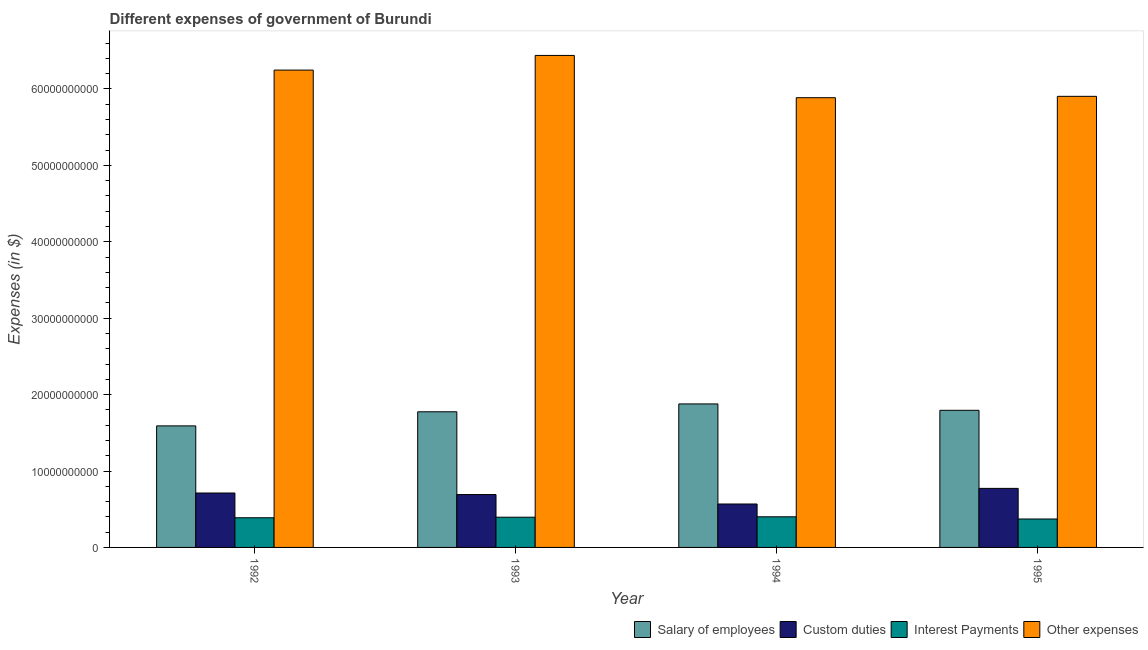How many different coloured bars are there?
Your response must be concise. 4. Are the number of bars per tick equal to the number of legend labels?
Your answer should be compact. Yes. Are the number of bars on each tick of the X-axis equal?
Your response must be concise. Yes. How many bars are there on the 1st tick from the right?
Ensure brevity in your answer.  4. What is the label of the 2nd group of bars from the left?
Your answer should be compact. 1993. What is the amount spent on interest payments in 1993?
Offer a terse response. 3.96e+09. Across all years, what is the maximum amount spent on interest payments?
Your response must be concise. 4.01e+09. Across all years, what is the minimum amount spent on custom duties?
Keep it short and to the point. 5.68e+09. In which year was the amount spent on other expenses minimum?
Your answer should be very brief. 1994. What is the total amount spent on salary of employees in the graph?
Provide a succinct answer. 7.04e+1. What is the difference between the amount spent on interest payments in 1993 and that in 1994?
Your answer should be compact. -5.20e+07. What is the difference between the amount spent on other expenses in 1993 and the amount spent on interest payments in 1995?
Your answer should be compact. 5.35e+09. What is the average amount spent on interest payments per year?
Your answer should be very brief. 3.89e+09. In how many years, is the amount spent on custom duties greater than 24000000000 $?
Keep it short and to the point. 0. What is the ratio of the amount spent on salary of employees in 1994 to that in 1995?
Your answer should be compact. 1.05. What is the difference between the highest and the second highest amount spent on interest payments?
Give a very brief answer. 5.20e+07. What is the difference between the highest and the lowest amount spent on salary of employees?
Offer a terse response. 2.87e+09. In how many years, is the amount spent on interest payments greater than the average amount spent on interest payments taken over all years?
Your response must be concise. 2. Is it the case that in every year, the sum of the amount spent on custom duties and amount spent on salary of employees is greater than the sum of amount spent on interest payments and amount spent on other expenses?
Ensure brevity in your answer.  No. What does the 4th bar from the left in 1993 represents?
Your answer should be very brief. Other expenses. What does the 3rd bar from the right in 1995 represents?
Your response must be concise. Custom duties. How many bars are there?
Give a very brief answer. 16. Are the values on the major ticks of Y-axis written in scientific E-notation?
Keep it short and to the point. No. Does the graph contain any zero values?
Ensure brevity in your answer.  No. Does the graph contain grids?
Your answer should be compact. No. Where does the legend appear in the graph?
Provide a short and direct response. Bottom right. How are the legend labels stacked?
Your response must be concise. Horizontal. What is the title of the graph?
Offer a very short reply. Different expenses of government of Burundi. What is the label or title of the X-axis?
Ensure brevity in your answer.  Year. What is the label or title of the Y-axis?
Offer a very short reply. Expenses (in $). What is the Expenses (in $) of Salary of employees in 1992?
Ensure brevity in your answer.  1.59e+1. What is the Expenses (in $) in Custom duties in 1992?
Give a very brief answer. 7.12e+09. What is the Expenses (in $) of Interest Payments in 1992?
Offer a terse response. 3.88e+09. What is the Expenses (in $) of Other expenses in 1992?
Make the answer very short. 6.25e+1. What is the Expenses (in $) in Salary of employees in 1993?
Your answer should be very brief. 1.78e+1. What is the Expenses (in $) of Custom duties in 1993?
Your answer should be very brief. 6.92e+09. What is the Expenses (in $) in Interest Payments in 1993?
Make the answer very short. 3.96e+09. What is the Expenses (in $) of Other expenses in 1993?
Ensure brevity in your answer.  6.44e+1. What is the Expenses (in $) in Salary of employees in 1994?
Ensure brevity in your answer.  1.88e+1. What is the Expenses (in $) in Custom duties in 1994?
Give a very brief answer. 5.68e+09. What is the Expenses (in $) in Interest Payments in 1994?
Provide a short and direct response. 4.01e+09. What is the Expenses (in $) of Other expenses in 1994?
Offer a terse response. 5.89e+1. What is the Expenses (in $) in Salary of employees in 1995?
Offer a very short reply. 1.79e+1. What is the Expenses (in $) of Custom duties in 1995?
Offer a very short reply. 7.73e+09. What is the Expenses (in $) in Interest Payments in 1995?
Offer a very short reply. 3.72e+09. What is the Expenses (in $) of Other expenses in 1995?
Provide a short and direct response. 5.90e+1. Across all years, what is the maximum Expenses (in $) of Salary of employees?
Make the answer very short. 1.88e+1. Across all years, what is the maximum Expenses (in $) in Custom duties?
Provide a succinct answer. 7.73e+09. Across all years, what is the maximum Expenses (in $) of Interest Payments?
Offer a very short reply. 4.01e+09. Across all years, what is the maximum Expenses (in $) in Other expenses?
Your response must be concise. 6.44e+1. Across all years, what is the minimum Expenses (in $) in Salary of employees?
Offer a very short reply. 1.59e+1. Across all years, what is the minimum Expenses (in $) in Custom duties?
Offer a very short reply. 5.68e+09. Across all years, what is the minimum Expenses (in $) of Interest Payments?
Offer a terse response. 3.72e+09. Across all years, what is the minimum Expenses (in $) in Other expenses?
Your answer should be very brief. 5.89e+1. What is the total Expenses (in $) in Salary of employees in the graph?
Your answer should be compact. 7.04e+1. What is the total Expenses (in $) of Custom duties in the graph?
Keep it short and to the point. 2.75e+1. What is the total Expenses (in $) in Interest Payments in the graph?
Offer a terse response. 1.56e+1. What is the total Expenses (in $) of Other expenses in the graph?
Your answer should be very brief. 2.45e+11. What is the difference between the Expenses (in $) in Salary of employees in 1992 and that in 1993?
Give a very brief answer. -1.84e+09. What is the difference between the Expenses (in $) of Custom duties in 1992 and that in 1993?
Ensure brevity in your answer.  2.04e+08. What is the difference between the Expenses (in $) in Interest Payments in 1992 and that in 1993?
Offer a terse response. -7.20e+07. What is the difference between the Expenses (in $) of Other expenses in 1992 and that in 1993?
Offer a terse response. -1.92e+09. What is the difference between the Expenses (in $) of Salary of employees in 1992 and that in 1994?
Provide a short and direct response. -2.87e+09. What is the difference between the Expenses (in $) in Custom duties in 1992 and that in 1994?
Ensure brevity in your answer.  1.44e+09. What is the difference between the Expenses (in $) in Interest Payments in 1992 and that in 1994?
Make the answer very short. -1.24e+08. What is the difference between the Expenses (in $) of Other expenses in 1992 and that in 1994?
Offer a very short reply. 3.62e+09. What is the difference between the Expenses (in $) in Salary of employees in 1992 and that in 1995?
Make the answer very short. -2.04e+09. What is the difference between the Expenses (in $) of Custom duties in 1992 and that in 1995?
Keep it short and to the point. -6.04e+08. What is the difference between the Expenses (in $) in Interest Payments in 1992 and that in 1995?
Your response must be concise. 1.61e+08. What is the difference between the Expenses (in $) in Other expenses in 1992 and that in 1995?
Your response must be concise. 3.44e+09. What is the difference between the Expenses (in $) in Salary of employees in 1993 and that in 1994?
Keep it short and to the point. -1.03e+09. What is the difference between the Expenses (in $) in Custom duties in 1993 and that in 1994?
Offer a very short reply. 1.24e+09. What is the difference between the Expenses (in $) of Interest Payments in 1993 and that in 1994?
Offer a very short reply. -5.20e+07. What is the difference between the Expenses (in $) in Other expenses in 1993 and that in 1994?
Ensure brevity in your answer.  5.53e+09. What is the difference between the Expenses (in $) of Salary of employees in 1993 and that in 1995?
Your answer should be compact. -1.95e+08. What is the difference between the Expenses (in $) in Custom duties in 1993 and that in 1995?
Give a very brief answer. -8.08e+08. What is the difference between the Expenses (in $) in Interest Payments in 1993 and that in 1995?
Your response must be concise. 2.33e+08. What is the difference between the Expenses (in $) in Other expenses in 1993 and that in 1995?
Keep it short and to the point. 5.35e+09. What is the difference between the Expenses (in $) of Salary of employees in 1994 and that in 1995?
Provide a short and direct response. 8.34e+08. What is the difference between the Expenses (in $) of Custom duties in 1994 and that in 1995?
Give a very brief answer. -2.04e+09. What is the difference between the Expenses (in $) in Interest Payments in 1994 and that in 1995?
Your response must be concise. 2.85e+08. What is the difference between the Expenses (in $) in Other expenses in 1994 and that in 1995?
Ensure brevity in your answer.  -1.79e+08. What is the difference between the Expenses (in $) in Salary of employees in 1992 and the Expenses (in $) in Custom duties in 1993?
Your response must be concise. 8.99e+09. What is the difference between the Expenses (in $) in Salary of employees in 1992 and the Expenses (in $) in Interest Payments in 1993?
Make the answer very short. 1.20e+1. What is the difference between the Expenses (in $) in Salary of employees in 1992 and the Expenses (in $) in Other expenses in 1993?
Your response must be concise. -4.85e+1. What is the difference between the Expenses (in $) of Custom duties in 1992 and the Expenses (in $) of Interest Payments in 1993?
Give a very brief answer. 3.17e+09. What is the difference between the Expenses (in $) in Custom duties in 1992 and the Expenses (in $) in Other expenses in 1993?
Provide a succinct answer. -5.73e+1. What is the difference between the Expenses (in $) in Interest Payments in 1992 and the Expenses (in $) in Other expenses in 1993?
Make the answer very short. -6.05e+1. What is the difference between the Expenses (in $) of Salary of employees in 1992 and the Expenses (in $) of Custom duties in 1994?
Your response must be concise. 1.02e+1. What is the difference between the Expenses (in $) of Salary of employees in 1992 and the Expenses (in $) of Interest Payments in 1994?
Your answer should be compact. 1.19e+1. What is the difference between the Expenses (in $) of Salary of employees in 1992 and the Expenses (in $) of Other expenses in 1994?
Your answer should be compact. -4.30e+1. What is the difference between the Expenses (in $) of Custom duties in 1992 and the Expenses (in $) of Interest Payments in 1994?
Offer a terse response. 3.12e+09. What is the difference between the Expenses (in $) of Custom duties in 1992 and the Expenses (in $) of Other expenses in 1994?
Make the answer very short. -5.17e+1. What is the difference between the Expenses (in $) in Interest Payments in 1992 and the Expenses (in $) in Other expenses in 1994?
Your answer should be very brief. -5.50e+1. What is the difference between the Expenses (in $) in Salary of employees in 1992 and the Expenses (in $) in Custom duties in 1995?
Offer a terse response. 8.18e+09. What is the difference between the Expenses (in $) in Salary of employees in 1992 and the Expenses (in $) in Interest Payments in 1995?
Your answer should be very brief. 1.22e+1. What is the difference between the Expenses (in $) in Salary of employees in 1992 and the Expenses (in $) in Other expenses in 1995?
Give a very brief answer. -4.31e+1. What is the difference between the Expenses (in $) of Custom duties in 1992 and the Expenses (in $) of Interest Payments in 1995?
Offer a terse response. 3.40e+09. What is the difference between the Expenses (in $) in Custom duties in 1992 and the Expenses (in $) in Other expenses in 1995?
Make the answer very short. -5.19e+1. What is the difference between the Expenses (in $) in Interest Payments in 1992 and the Expenses (in $) in Other expenses in 1995?
Offer a terse response. -5.52e+1. What is the difference between the Expenses (in $) in Salary of employees in 1993 and the Expenses (in $) in Custom duties in 1994?
Offer a very short reply. 1.21e+1. What is the difference between the Expenses (in $) of Salary of employees in 1993 and the Expenses (in $) of Interest Payments in 1994?
Give a very brief answer. 1.37e+1. What is the difference between the Expenses (in $) of Salary of employees in 1993 and the Expenses (in $) of Other expenses in 1994?
Give a very brief answer. -4.11e+1. What is the difference between the Expenses (in $) of Custom duties in 1993 and the Expenses (in $) of Interest Payments in 1994?
Your answer should be compact. 2.91e+09. What is the difference between the Expenses (in $) of Custom duties in 1993 and the Expenses (in $) of Other expenses in 1994?
Give a very brief answer. -5.19e+1. What is the difference between the Expenses (in $) in Interest Payments in 1993 and the Expenses (in $) in Other expenses in 1994?
Your answer should be compact. -5.49e+1. What is the difference between the Expenses (in $) of Salary of employees in 1993 and the Expenses (in $) of Custom duties in 1995?
Ensure brevity in your answer.  1.00e+1. What is the difference between the Expenses (in $) in Salary of employees in 1993 and the Expenses (in $) in Interest Payments in 1995?
Keep it short and to the point. 1.40e+1. What is the difference between the Expenses (in $) in Salary of employees in 1993 and the Expenses (in $) in Other expenses in 1995?
Ensure brevity in your answer.  -4.13e+1. What is the difference between the Expenses (in $) of Custom duties in 1993 and the Expenses (in $) of Interest Payments in 1995?
Make the answer very short. 3.20e+09. What is the difference between the Expenses (in $) in Custom duties in 1993 and the Expenses (in $) in Other expenses in 1995?
Your answer should be very brief. -5.21e+1. What is the difference between the Expenses (in $) of Interest Payments in 1993 and the Expenses (in $) of Other expenses in 1995?
Offer a terse response. -5.51e+1. What is the difference between the Expenses (in $) in Salary of employees in 1994 and the Expenses (in $) in Custom duties in 1995?
Give a very brief answer. 1.11e+1. What is the difference between the Expenses (in $) of Salary of employees in 1994 and the Expenses (in $) of Interest Payments in 1995?
Make the answer very short. 1.51e+1. What is the difference between the Expenses (in $) in Salary of employees in 1994 and the Expenses (in $) in Other expenses in 1995?
Provide a short and direct response. -4.03e+1. What is the difference between the Expenses (in $) in Custom duties in 1994 and the Expenses (in $) in Interest Payments in 1995?
Make the answer very short. 1.96e+09. What is the difference between the Expenses (in $) in Custom duties in 1994 and the Expenses (in $) in Other expenses in 1995?
Offer a terse response. -5.34e+1. What is the difference between the Expenses (in $) of Interest Payments in 1994 and the Expenses (in $) of Other expenses in 1995?
Ensure brevity in your answer.  -5.50e+1. What is the average Expenses (in $) of Salary of employees per year?
Your answer should be compact. 1.76e+1. What is the average Expenses (in $) of Custom duties per year?
Ensure brevity in your answer.  6.86e+09. What is the average Expenses (in $) of Interest Payments per year?
Offer a terse response. 3.89e+09. What is the average Expenses (in $) in Other expenses per year?
Make the answer very short. 6.12e+1. In the year 1992, what is the difference between the Expenses (in $) in Salary of employees and Expenses (in $) in Custom duties?
Provide a succinct answer. 8.78e+09. In the year 1992, what is the difference between the Expenses (in $) in Salary of employees and Expenses (in $) in Interest Payments?
Offer a very short reply. 1.20e+1. In the year 1992, what is the difference between the Expenses (in $) in Salary of employees and Expenses (in $) in Other expenses?
Ensure brevity in your answer.  -4.66e+1. In the year 1992, what is the difference between the Expenses (in $) of Custom duties and Expenses (in $) of Interest Payments?
Ensure brevity in your answer.  3.24e+09. In the year 1992, what is the difference between the Expenses (in $) of Custom duties and Expenses (in $) of Other expenses?
Offer a very short reply. -5.54e+1. In the year 1992, what is the difference between the Expenses (in $) in Interest Payments and Expenses (in $) in Other expenses?
Ensure brevity in your answer.  -5.86e+1. In the year 1993, what is the difference between the Expenses (in $) in Salary of employees and Expenses (in $) in Custom duties?
Offer a very short reply. 1.08e+1. In the year 1993, what is the difference between the Expenses (in $) in Salary of employees and Expenses (in $) in Interest Payments?
Make the answer very short. 1.38e+1. In the year 1993, what is the difference between the Expenses (in $) in Salary of employees and Expenses (in $) in Other expenses?
Offer a terse response. -4.66e+1. In the year 1993, what is the difference between the Expenses (in $) in Custom duties and Expenses (in $) in Interest Payments?
Provide a succinct answer. 2.96e+09. In the year 1993, what is the difference between the Expenses (in $) in Custom duties and Expenses (in $) in Other expenses?
Your answer should be compact. -5.75e+1. In the year 1993, what is the difference between the Expenses (in $) in Interest Payments and Expenses (in $) in Other expenses?
Offer a terse response. -6.04e+1. In the year 1994, what is the difference between the Expenses (in $) in Salary of employees and Expenses (in $) in Custom duties?
Make the answer very short. 1.31e+1. In the year 1994, what is the difference between the Expenses (in $) in Salary of employees and Expenses (in $) in Interest Payments?
Provide a short and direct response. 1.48e+1. In the year 1994, what is the difference between the Expenses (in $) in Salary of employees and Expenses (in $) in Other expenses?
Your response must be concise. -4.01e+1. In the year 1994, what is the difference between the Expenses (in $) in Custom duties and Expenses (in $) in Interest Payments?
Provide a short and direct response. 1.68e+09. In the year 1994, what is the difference between the Expenses (in $) of Custom duties and Expenses (in $) of Other expenses?
Provide a succinct answer. -5.32e+1. In the year 1994, what is the difference between the Expenses (in $) of Interest Payments and Expenses (in $) of Other expenses?
Provide a short and direct response. -5.49e+1. In the year 1995, what is the difference between the Expenses (in $) of Salary of employees and Expenses (in $) of Custom duties?
Offer a very short reply. 1.02e+1. In the year 1995, what is the difference between the Expenses (in $) in Salary of employees and Expenses (in $) in Interest Payments?
Offer a terse response. 1.42e+1. In the year 1995, what is the difference between the Expenses (in $) of Salary of employees and Expenses (in $) of Other expenses?
Offer a terse response. -4.11e+1. In the year 1995, what is the difference between the Expenses (in $) in Custom duties and Expenses (in $) in Interest Payments?
Provide a succinct answer. 4.00e+09. In the year 1995, what is the difference between the Expenses (in $) of Custom duties and Expenses (in $) of Other expenses?
Keep it short and to the point. -5.13e+1. In the year 1995, what is the difference between the Expenses (in $) of Interest Payments and Expenses (in $) of Other expenses?
Provide a short and direct response. -5.53e+1. What is the ratio of the Expenses (in $) in Salary of employees in 1992 to that in 1993?
Offer a very short reply. 0.9. What is the ratio of the Expenses (in $) of Custom duties in 1992 to that in 1993?
Provide a succinct answer. 1.03. What is the ratio of the Expenses (in $) of Interest Payments in 1992 to that in 1993?
Offer a very short reply. 0.98. What is the ratio of the Expenses (in $) of Other expenses in 1992 to that in 1993?
Give a very brief answer. 0.97. What is the ratio of the Expenses (in $) of Salary of employees in 1992 to that in 1994?
Provide a succinct answer. 0.85. What is the ratio of the Expenses (in $) of Custom duties in 1992 to that in 1994?
Keep it short and to the point. 1.25. What is the ratio of the Expenses (in $) of Interest Payments in 1992 to that in 1994?
Offer a terse response. 0.97. What is the ratio of the Expenses (in $) of Other expenses in 1992 to that in 1994?
Offer a terse response. 1.06. What is the ratio of the Expenses (in $) in Salary of employees in 1992 to that in 1995?
Provide a succinct answer. 0.89. What is the ratio of the Expenses (in $) in Custom duties in 1992 to that in 1995?
Give a very brief answer. 0.92. What is the ratio of the Expenses (in $) of Interest Payments in 1992 to that in 1995?
Make the answer very short. 1.04. What is the ratio of the Expenses (in $) in Other expenses in 1992 to that in 1995?
Ensure brevity in your answer.  1.06. What is the ratio of the Expenses (in $) in Salary of employees in 1993 to that in 1994?
Your response must be concise. 0.95. What is the ratio of the Expenses (in $) of Custom duties in 1993 to that in 1994?
Ensure brevity in your answer.  1.22. What is the ratio of the Expenses (in $) in Interest Payments in 1993 to that in 1994?
Your response must be concise. 0.99. What is the ratio of the Expenses (in $) in Other expenses in 1993 to that in 1994?
Offer a very short reply. 1.09. What is the ratio of the Expenses (in $) in Salary of employees in 1993 to that in 1995?
Provide a short and direct response. 0.99. What is the ratio of the Expenses (in $) of Custom duties in 1993 to that in 1995?
Provide a succinct answer. 0.9. What is the ratio of the Expenses (in $) of Interest Payments in 1993 to that in 1995?
Your answer should be compact. 1.06. What is the ratio of the Expenses (in $) in Other expenses in 1993 to that in 1995?
Provide a succinct answer. 1.09. What is the ratio of the Expenses (in $) in Salary of employees in 1994 to that in 1995?
Keep it short and to the point. 1.05. What is the ratio of the Expenses (in $) in Custom duties in 1994 to that in 1995?
Provide a short and direct response. 0.74. What is the ratio of the Expenses (in $) in Interest Payments in 1994 to that in 1995?
Offer a terse response. 1.08. What is the difference between the highest and the second highest Expenses (in $) in Salary of employees?
Your response must be concise. 8.34e+08. What is the difference between the highest and the second highest Expenses (in $) of Custom duties?
Offer a very short reply. 6.04e+08. What is the difference between the highest and the second highest Expenses (in $) in Interest Payments?
Offer a very short reply. 5.20e+07. What is the difference between the highest and the second highest Expenses (in $) in Other expenses?
Keep it short and to the point. 1.92e+09. What is the difference between the highest and the lowest Expenses (in $) in Salary of employees?
Keep it short and to the point. 2.87e+09. What is the difference between the highest and the lowest Expenses (in $) in Custom duties?
Your answer should be very brief. 2.04e+09. What is the difference between the highest and the lowest Expenses (in $) in Interest Payments?
Your response must be concise. 2.85e+08. What is the difference between the highest and the lowest Expenses (in $) in Other expenses?
Your answer should be very brief. 5.53e+09. 